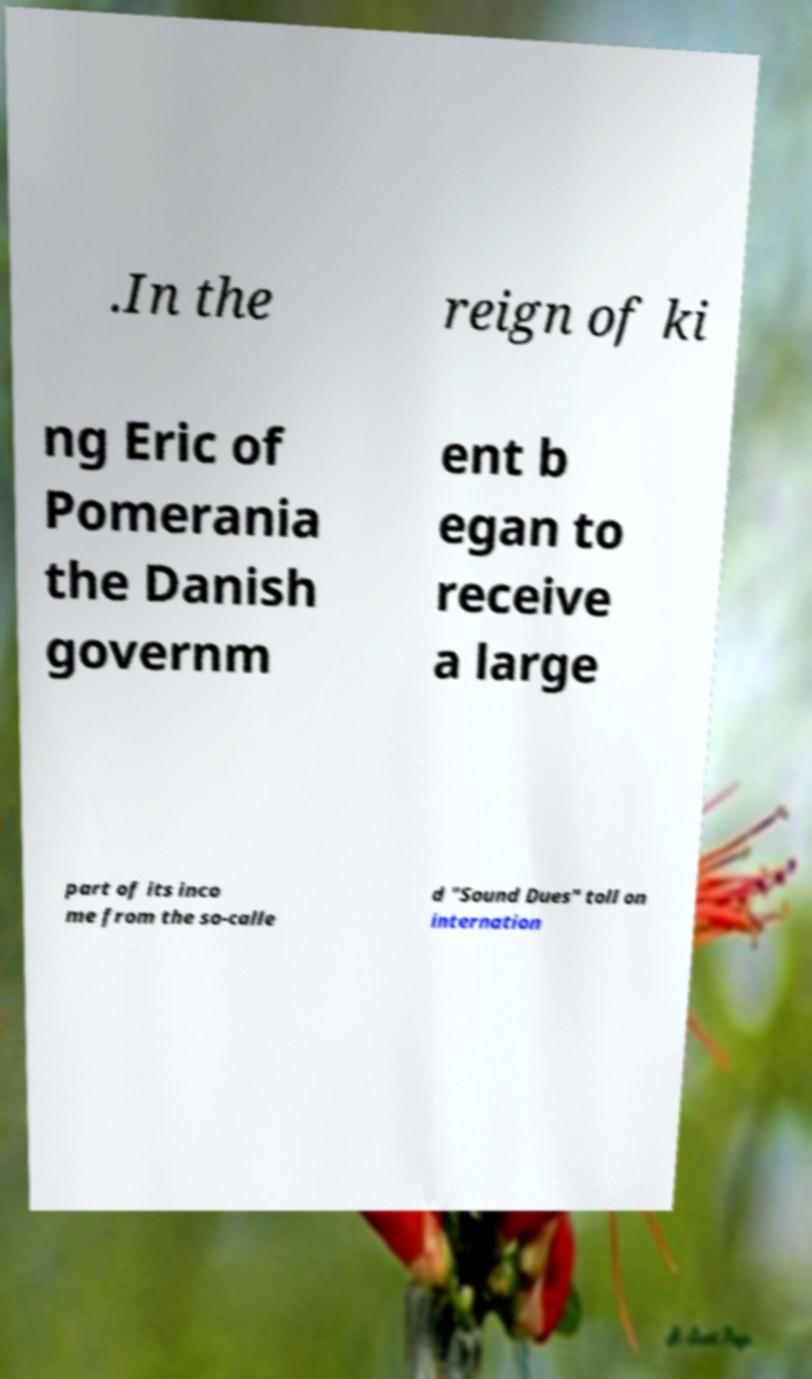What messages or text are displayed in this image? I need them in a readable, typed format. .In the reign of ki ng Eric of Pomerania the Danish governm ent b egan to receive a large part of its inco me from the so-calle d "Sound Dues" toll on internation 